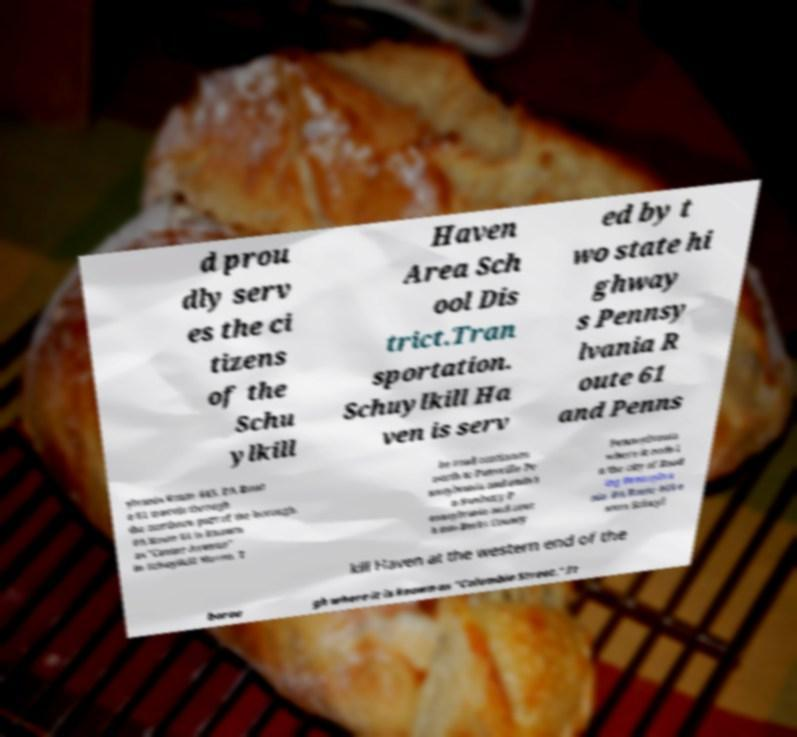Could you extract and type out the text from this image? d prou dly serv es the ci tizens of the Schu ylkill Haven Area Sch ool Dis trict.Tran sportation. Schuylkill Ha ven is serv ed by t wo state hi ghway s Pennsy lvania R oute 61 and Penns ylvania Route 443. PA Rout e 61 travels through the northern part of the borough. PA Route 61 is known as "Center Avenue" in Schuylkill Haven. T he road continues north to Pottsville Pe nnsylvania and ends i n Sunbury P ennsylvania and sout h into Berks County Pennsylvania where it ends i n the city of Read ing Pennsylva nia. PA Route 443 e nters Schuyl kill Haven at the western end of the borou gh where it is known as "Columbia Street." It 